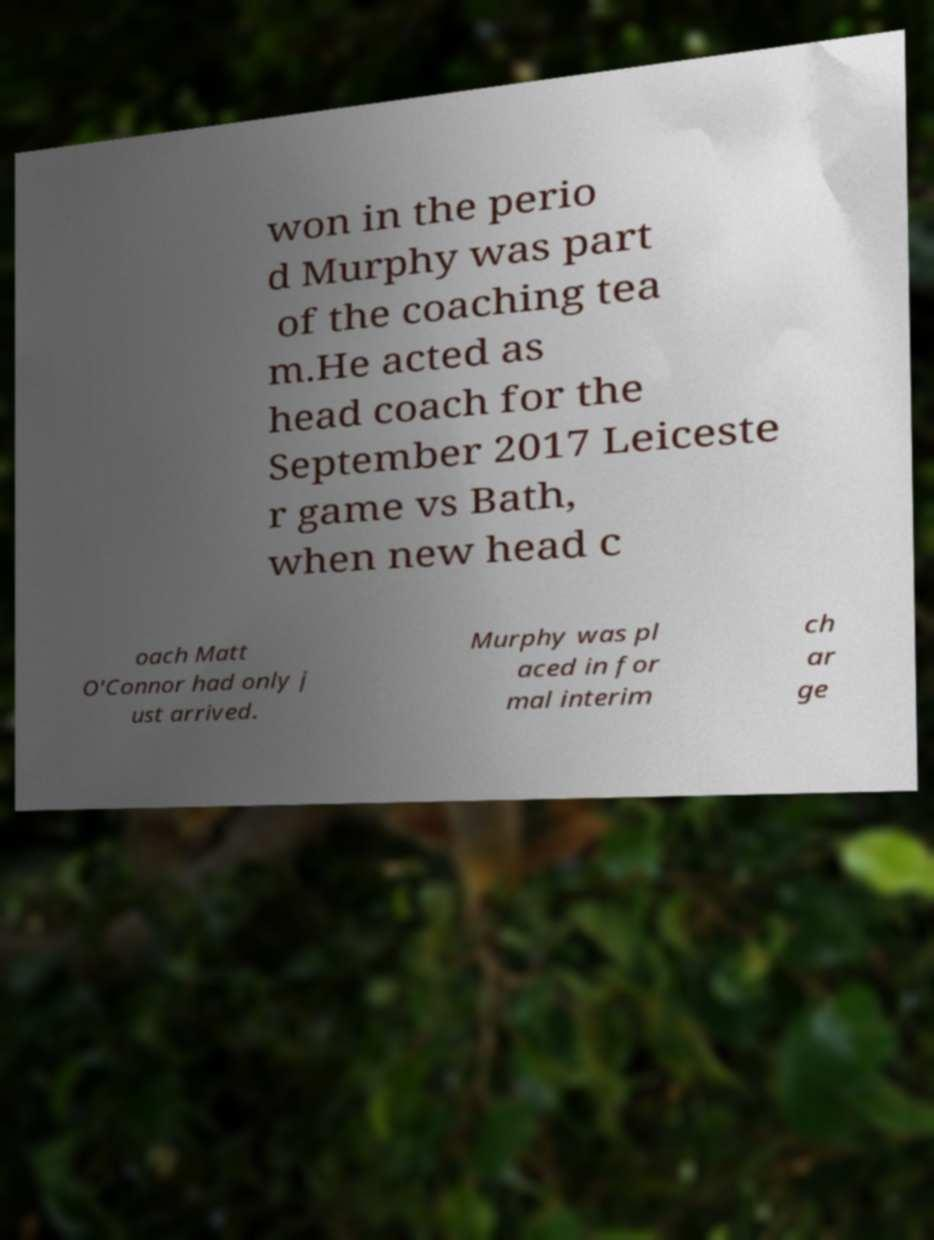What messages or text are displayed in this image? I need them in a readable, typed format. won in the perio d Murphy was part of the coaching tea m.He acted as head coach for the September 2017 Leiceste r game vs Bath, when new head c oach Matt O'Connor had only j ust arrived. Murphy was pl aced in for mal interim ch ar ge 